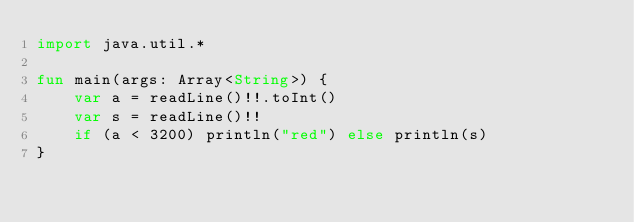Convert code to text. <code><loc_0><loc_0><loc_500><loc_500><_Kotlin_>import java.util.*

fun main(args: Array<String>) {
    var a = readLine()!!.toInt()
    var s = readLine()!!
    if (a < 3200) println("red") else println(s)
}
</code> 